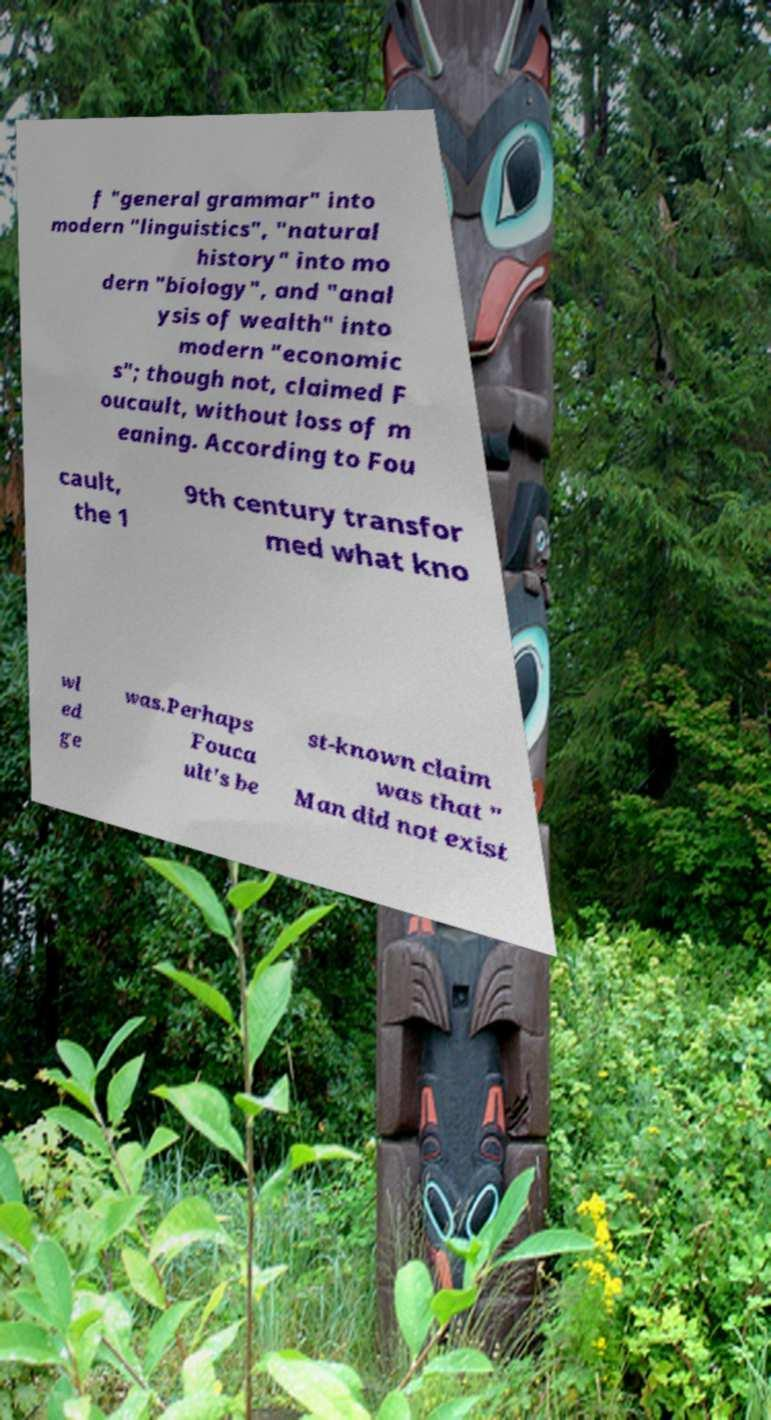For documentation purposes, I need the text within this image transcribed. Could you provide that? f "general grammar" into modern "linguistics", "natural history" into mo dern "biology", and "anal ysis of wealth" into modern "economic s"; though not, claimed F oucault, without loss of m eaning. According to Fou cault, the 1 9th century transfor med what kno wl ed ge was.Perhaps Fouca ult's be st-known claim was that " Man did not exist 